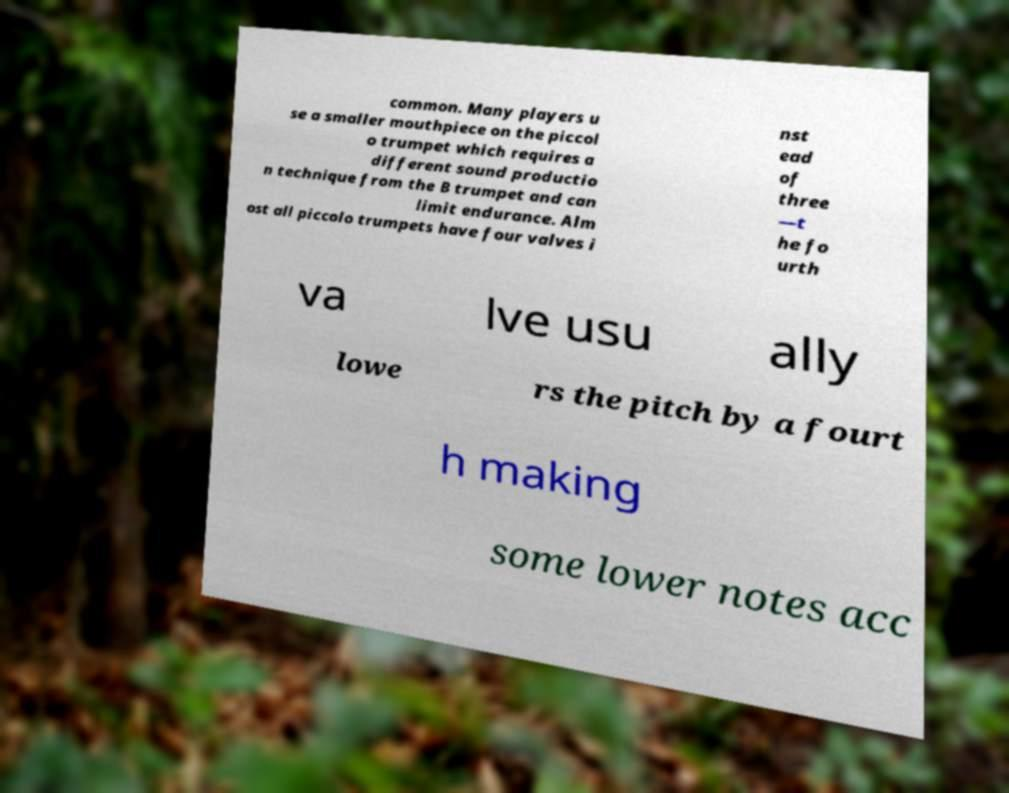For documentation purposes, I need the text within this image transcribed. Could you provide that? common. Many players u se a smaller mouthpiece on the piccol o trumpet which requires a different sound productio n technique from the B trumpet and can limit endurance. Alm ost all piccolo trumpets have four valves i nst ead of three —t he fo urth va lve usu ally lowe rs the pitch by a fourt h making some lower notes acc 